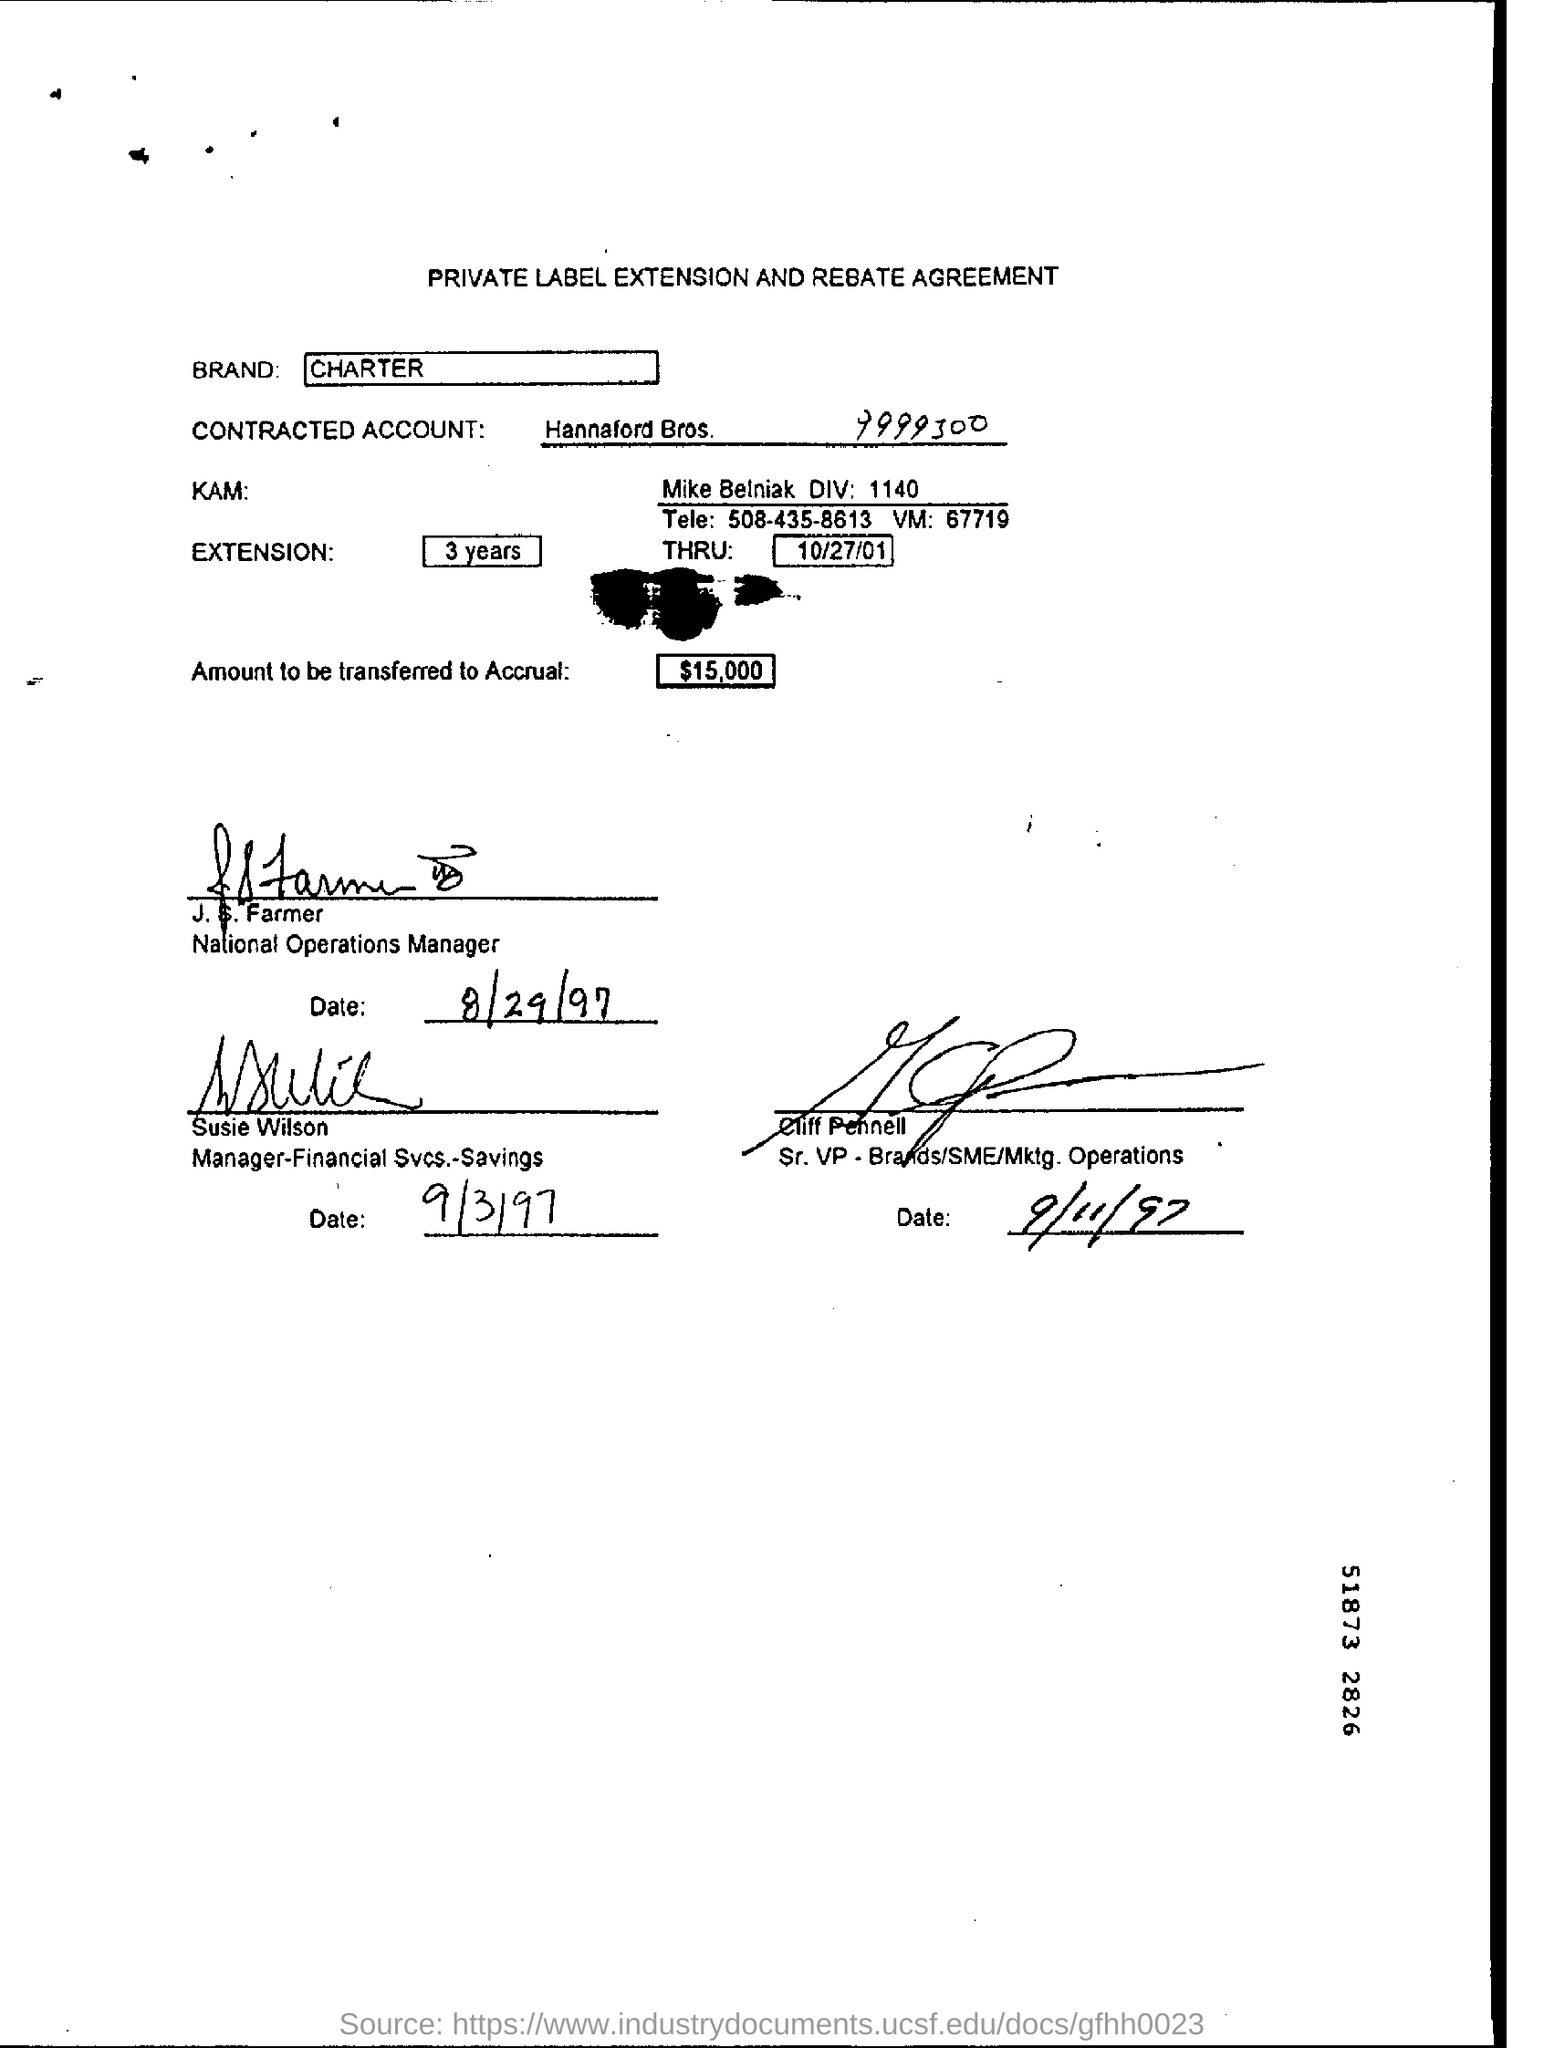What is written in the Letter Head ?
Provide a short and direct response. PRIVATE LABEL EXTENSION AND REBATE AGREEMENT. What is the Brand Name ?
Keep it short and to the point. CHARTER. How much amount to be transferred to Accrual ?
Provide a short and direct response. $15,000. What is the Contracted Account Number ?
Keep it short and to the point. 9999300. What is written in the Extension  Field ?
Your response must be concise. 3 years. What is written in the THRU Filed ?
Ensure brevity in your answer.  10/27/01. Who is the Manger of Financial SVCS -Savings ?
Offer a terse response. Susie Wilson. 